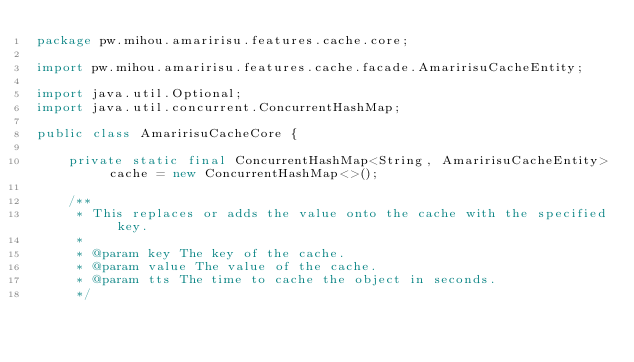<code> <loc_0><loc_0><loc_500><loc_500><_Java_>package pw.mihou.amaririsu.features.cache.core;

import pw.mihou.amaririsu.features.cache.facade.AmaririsuCacheEntity;

import java.util.Optional;
import java.util.concurrent.ConcurrentHashMap;

public class AmaririsuCacheCore {

    private static final ConcurrentHashMap<String, AmaririsuCacheEntity> cache = new ConcurrentHashMap<>();

    /**
     * This replaces or adds the value onto the cache with the specified key.
     *
     * @param key The key of the cache.
     * @param value The value of the cache.
     * @param tts The time to cache the object in seconds.
     */</code> 